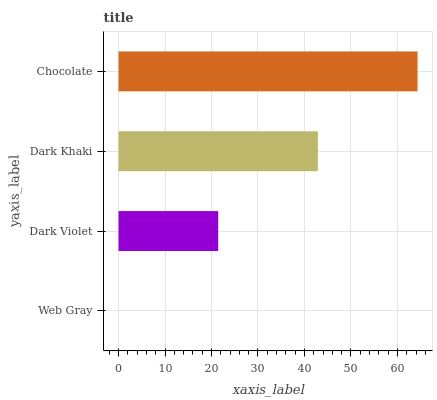Is Web Gray the minimum?
Answer yes or no. Yes. Is Chocolate the maximum?
Answer yes or no. Yes. Is Dark Violet the minimum?
Answer yes or no. No. Is Dark Violet the maximum?
Answer yes or no. No. Is Dark Violet greater than Web Gray?
Answer yes or no. Yes. Is Web Gray less than Dark Violet?
Answer yes or no. Yes. Is Web Gray greater than Dark Violet?
Answer yes or no. No. Is Dark Violet less than Web Gray?
Answer yes or no. No. Is Dark Khaki the high median?
Answer yes or no. Yes. Is Dark Violet the low median?
Answer yes or no. Yes. Is Dark Violet the high median?
Answer yes or no. No. Is Chocolate the low median?
Answer yes or no. No. 